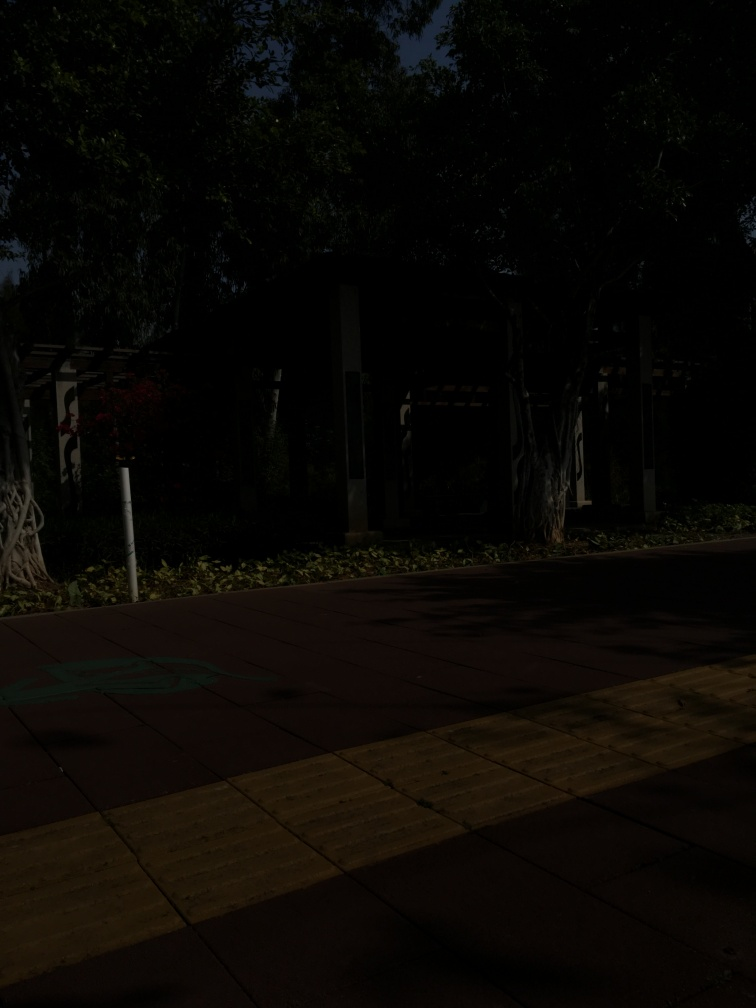Could you describe the type of vegetation visible in the photo? Although the image is quite dark, it is possible to discern tall trees with dense canopies and shrubbery, which suggests a well-planted area with a variety of greenery that might offer shade and scenic value to visitors. Does the image suggest any cultural or regional characteristics? Due to the limited visibility in the image, specific cultural or regional characteristics are not distinctly apparent. The presence of a lush vegetation and structured pathways could hint at a park in a region that values outdoor recreational spaces. 